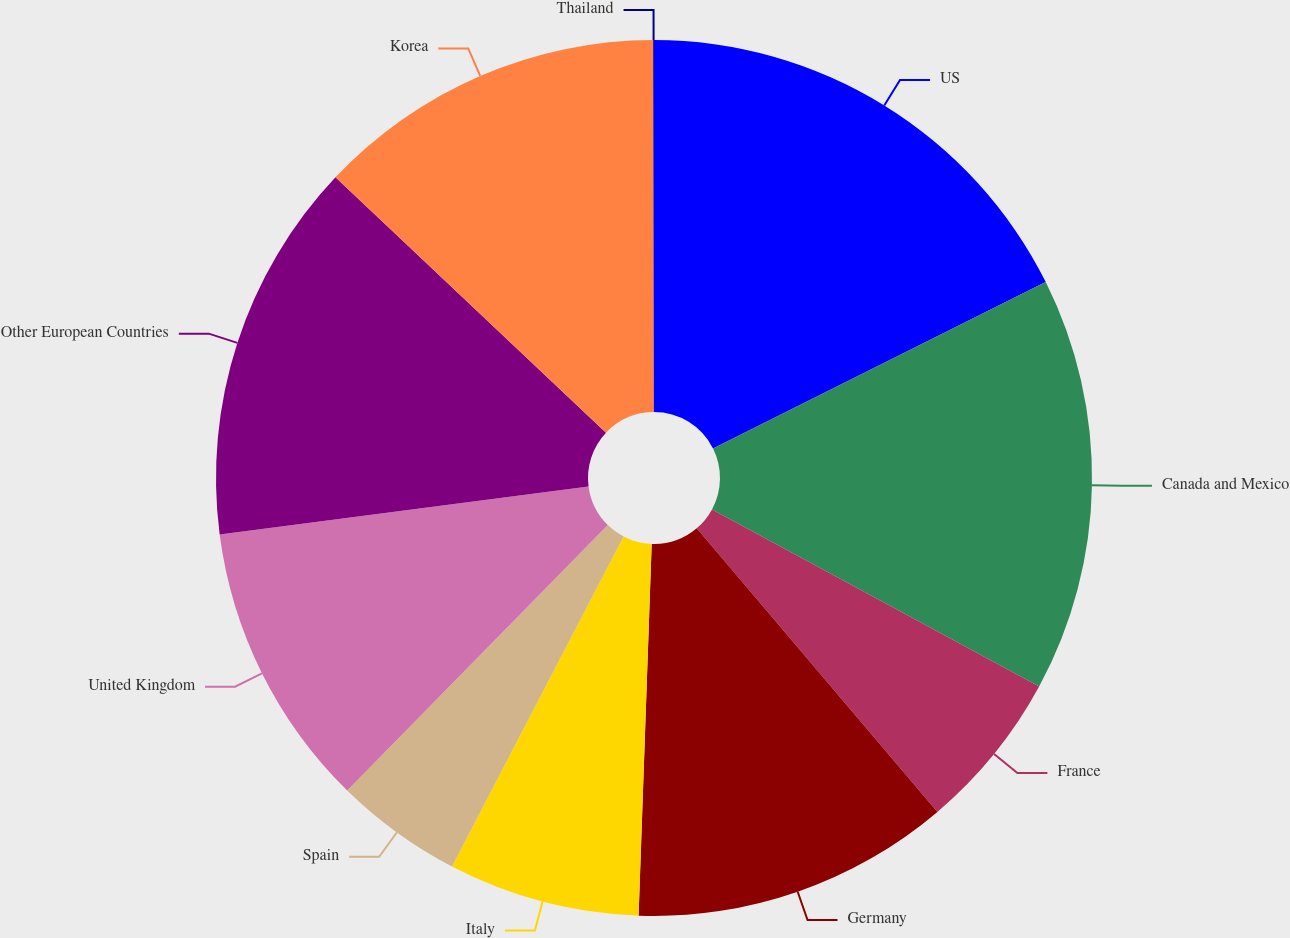<chart> <loc_0><loc_0><loc_500><loc_500><pie_chart><fcel>US<fcel>Canada and Mexico<fcel>France<fcel>Germany<fcel>Italy<fcel>Spain<fcel>United Kingdom<fcel>Other European Countries<fcel>Korea<fcel>Thailand<nl><fcel>17.62%<fcel>15.28%<fcel>5.9%<fcel>11.76%<fcel>7.07%<fcel>4.72%<fcel>10.59%<fcel>14.1%<fcel>12.93%<fcel>0.03%<nl></chart> 